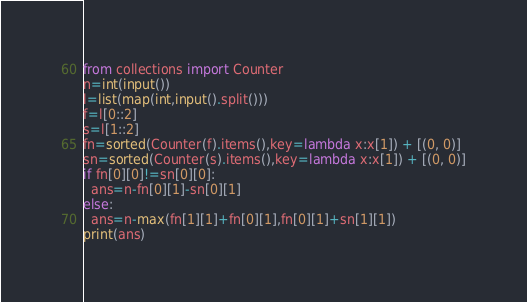Convert code to text. <code><loc_0><loc_0><loc_500><loc_500><_Python_>from collections import Counter
n=int(input())
l=list(map(int,input().split()))
f=l[0::2]
s=l[1::2]
fn=sorted(Counter(f).items(),key=lambda x:x[1]) + [(0, 0)]
sn=sorted(Counter(s).items(),key=lambda x:x[1]) + [(0, 0)]
if fn[0][0]!=sn[0][0]:
  ans=n-fn[0][1]-sn[0][1]
else:
  ans=n-max(fn[1][1]+fn[0][1],fn[0][1]+sn[1][1])
print(ans)</code> 